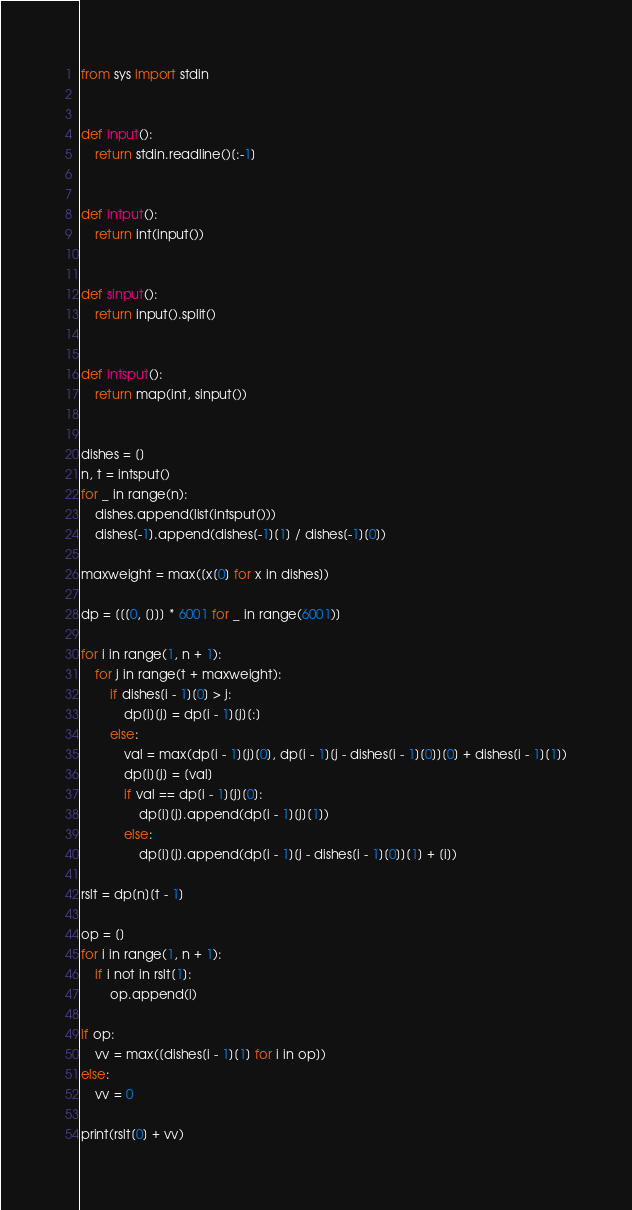Convert code to text. <code><loc_0><loc_0><loc_500><loc_500><_Python_>from sys import stdin


def input():
    return stdin.readline()[:-1]


def intput():
    return int(input())


def sinput():
    return input().split()


def intsput():
    return map(int, sinput())


dishes = []
n, t = intsput()
for _ in range(n):
    dishes.append(list(intsput()))
    dishes[-1].append(dishes[-1][1] / dishes[-1][0])

maxweight = max([x[0] for x in dishes])

dp = [[[0, []]] * 6001 for _ in range(6001)]

for i in range(1, n + 1):
    for j in range(t + maxweight):
        if dishes[i - 1][0] > j:
            dp[i][j] = dp[i - 1][j][:]
        else:
            val = max(dp[i - 1][j][0], dp[i - 1][j - dishes[i - 1][0]][0] + dishes[i - 1][1])
            dp[i][j] = [val]
            if val == dp[i - 1][j][0]:
                dp[i][j].append(dp[i - 1][j][1])
            else:
                dp[i][j].append(dp[i - 1][j - dishes[i - 1][0]][1] + [i])

rslt = dp[n][t - 1]

op = []
for i in range(1, n + 1):
    if i not in rslt[1]:
        op.append(i)

if op:
    vv = max([dishes[i - 1][1] for i in op])
else:
    vv = 0

print(rslt[0] + vv)
</code> 